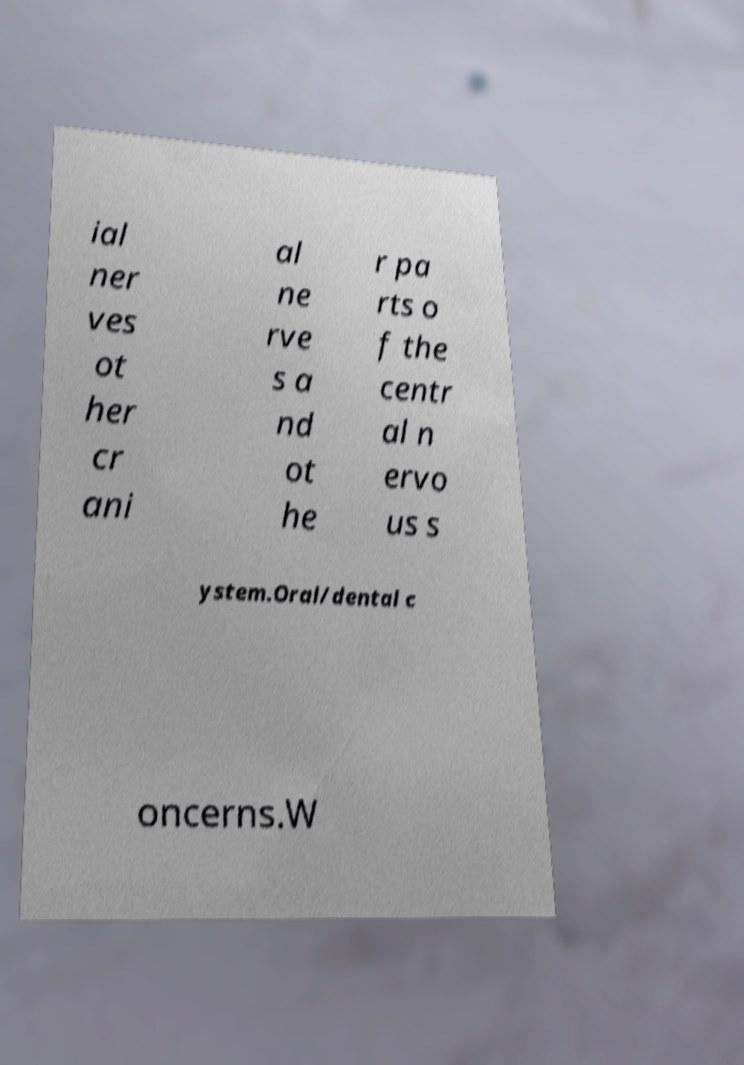Can you accurately transcribe the text from the provided image for me? ial ner ves ot her cr ani al ne rve s a nd ot he r pa rts o f the centr al n ervo us s ystem.Oral/dental c oncerns.W 